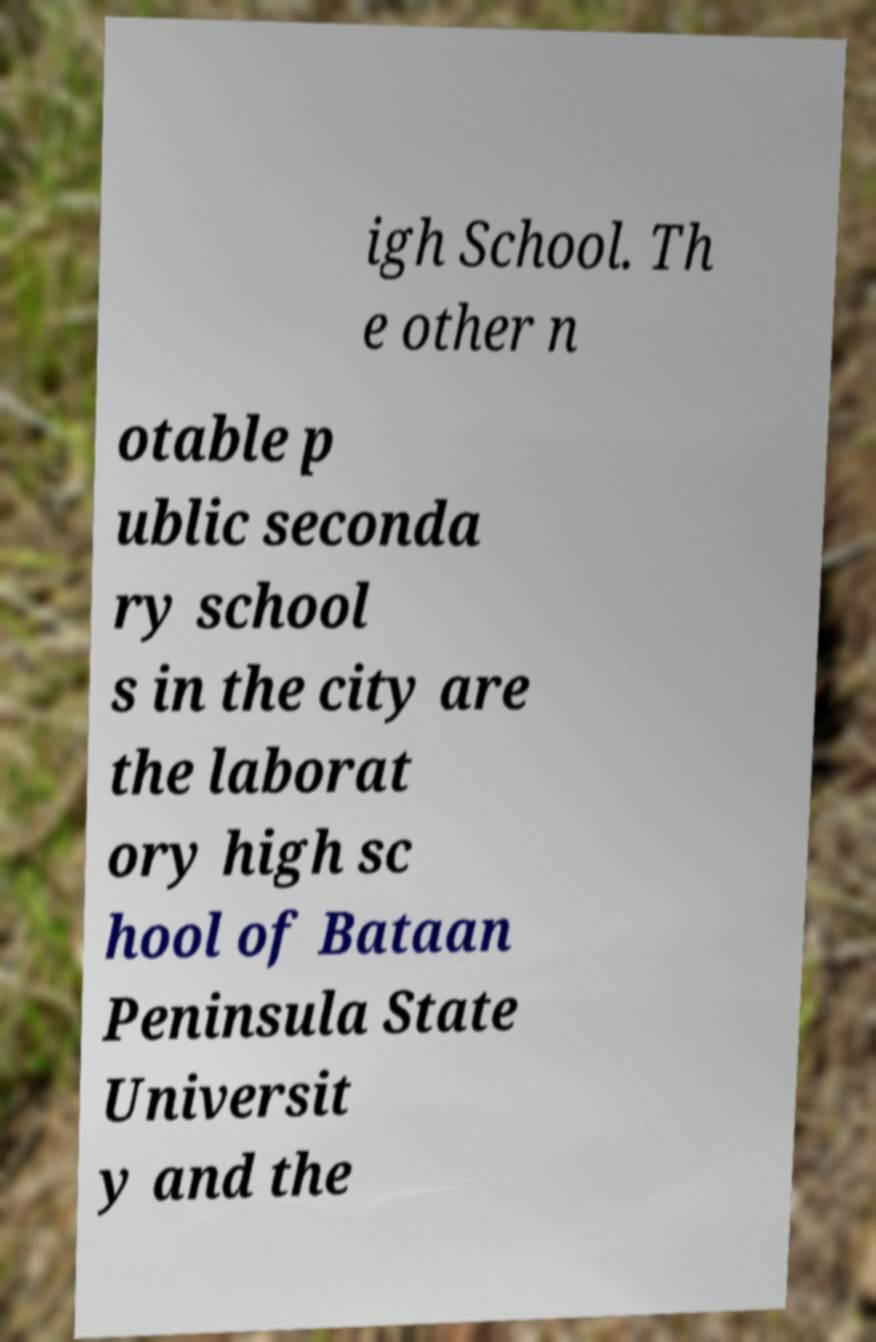There's text embedded in this image that I need extracted. Can you transcribe it verbatim? igh School. Th e other n otable p ublic seconda ry school s in the city are the laborat ory high sc hool of Bataan Peninsula State Universit y and the 